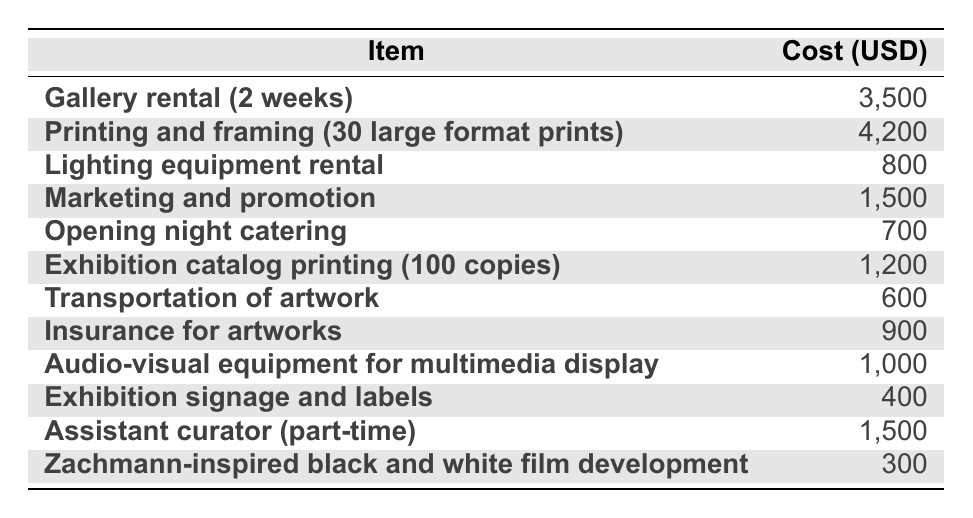What is the total cost for gallery rental? The table lists the cost of gallery rental as 3,500 USD. Therefore, the total cost for gallery rental is simply that figure.
Answer: 3,500 What is the cost for printing and framing 30 large format prints? The table specifies that the cost for printing and framing 30 large format prints is 4,200 USD, which is the exact amount provided.
Answer: 4,200 How much did the exhibition catalog printing cost? According to the table, the cost for exhibition catalog printing (100 copies) is listed as 1,200 USD. Thus, that is the total cost for printing.
Answer: 1,200 What is the total cost of opening night catering and transportation of artwork combined? The cost of opening night catering is 700 USD and the cost of transportation of artwork is 600 USD. Adding these two amounts gives 700 + 600 = 1,300 USD.
Answer: 1,300 Did the cost for Zachmann-inspired black and white film development exceed 500 USD? The cost for Zachmann-inspired black and white film development is listed as 300 USD, which is less than 500 USD. Therefore, the answer is no.
Answer: No What is the total amount spent on marketing and promotion, assistant curator, and insurance for artworks? The cost for marketing and promotion is 1,500 USD, assistant curator is also 1,500 USD, and insurance for artworks is 900 USD. Adding these amounts together gives 1,500 + 1,500 + 900 = 3,900 USD total.
Answer: 3,900 Is the cost for lighting equipment rental greater than the cost for exhibition signage and labels? The cost for lighting equipment rental is 800 USD, while the cost for exhibition signage and labels is 400 USD. Since 800 is greater than 400, the answer is yes.
Answer: Yes What is the average cost of the items listed in the table? To find the average, I first add all the costs: 3,500 + 4,200 + 800 + 1,500 + 700 + 1,200 + 600 + 900 + 1,000 + 400 + 1,500 + 300 = 18,100. There are 12 items, so the average is 18,100 / 12 = 1,508.33 (approximately).
Answer: 1,508.33 Which item incurred the highest cost in the table? By examining the costs listed, the item with the highest cost is printing and framing (30 large format prints) at 4,200 USD.
Answer: Printing and framing (30 large format prints) 